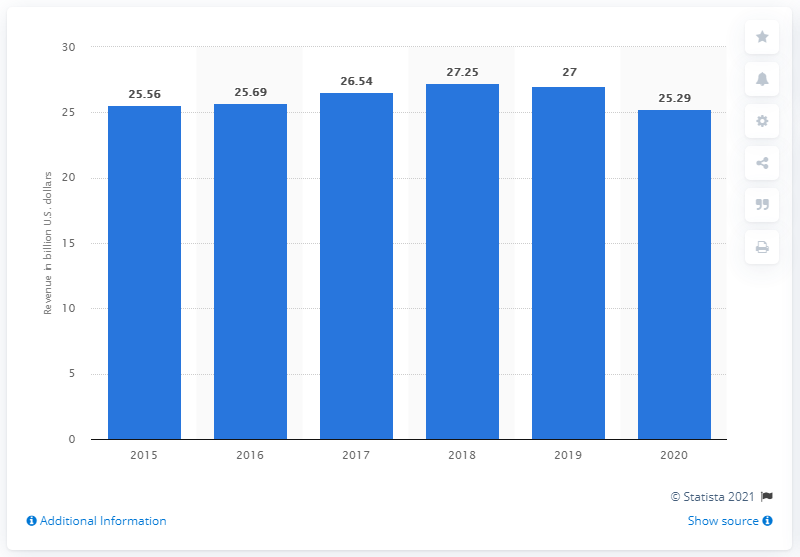Outline some significant characteristics in this image. In 2020, the revenue generated was higher than in 2015. In 2020, ViacomCBS generated revenue totaling 25.29 billion US dollars. In 2018, the year with the highest revenue was recorded. 